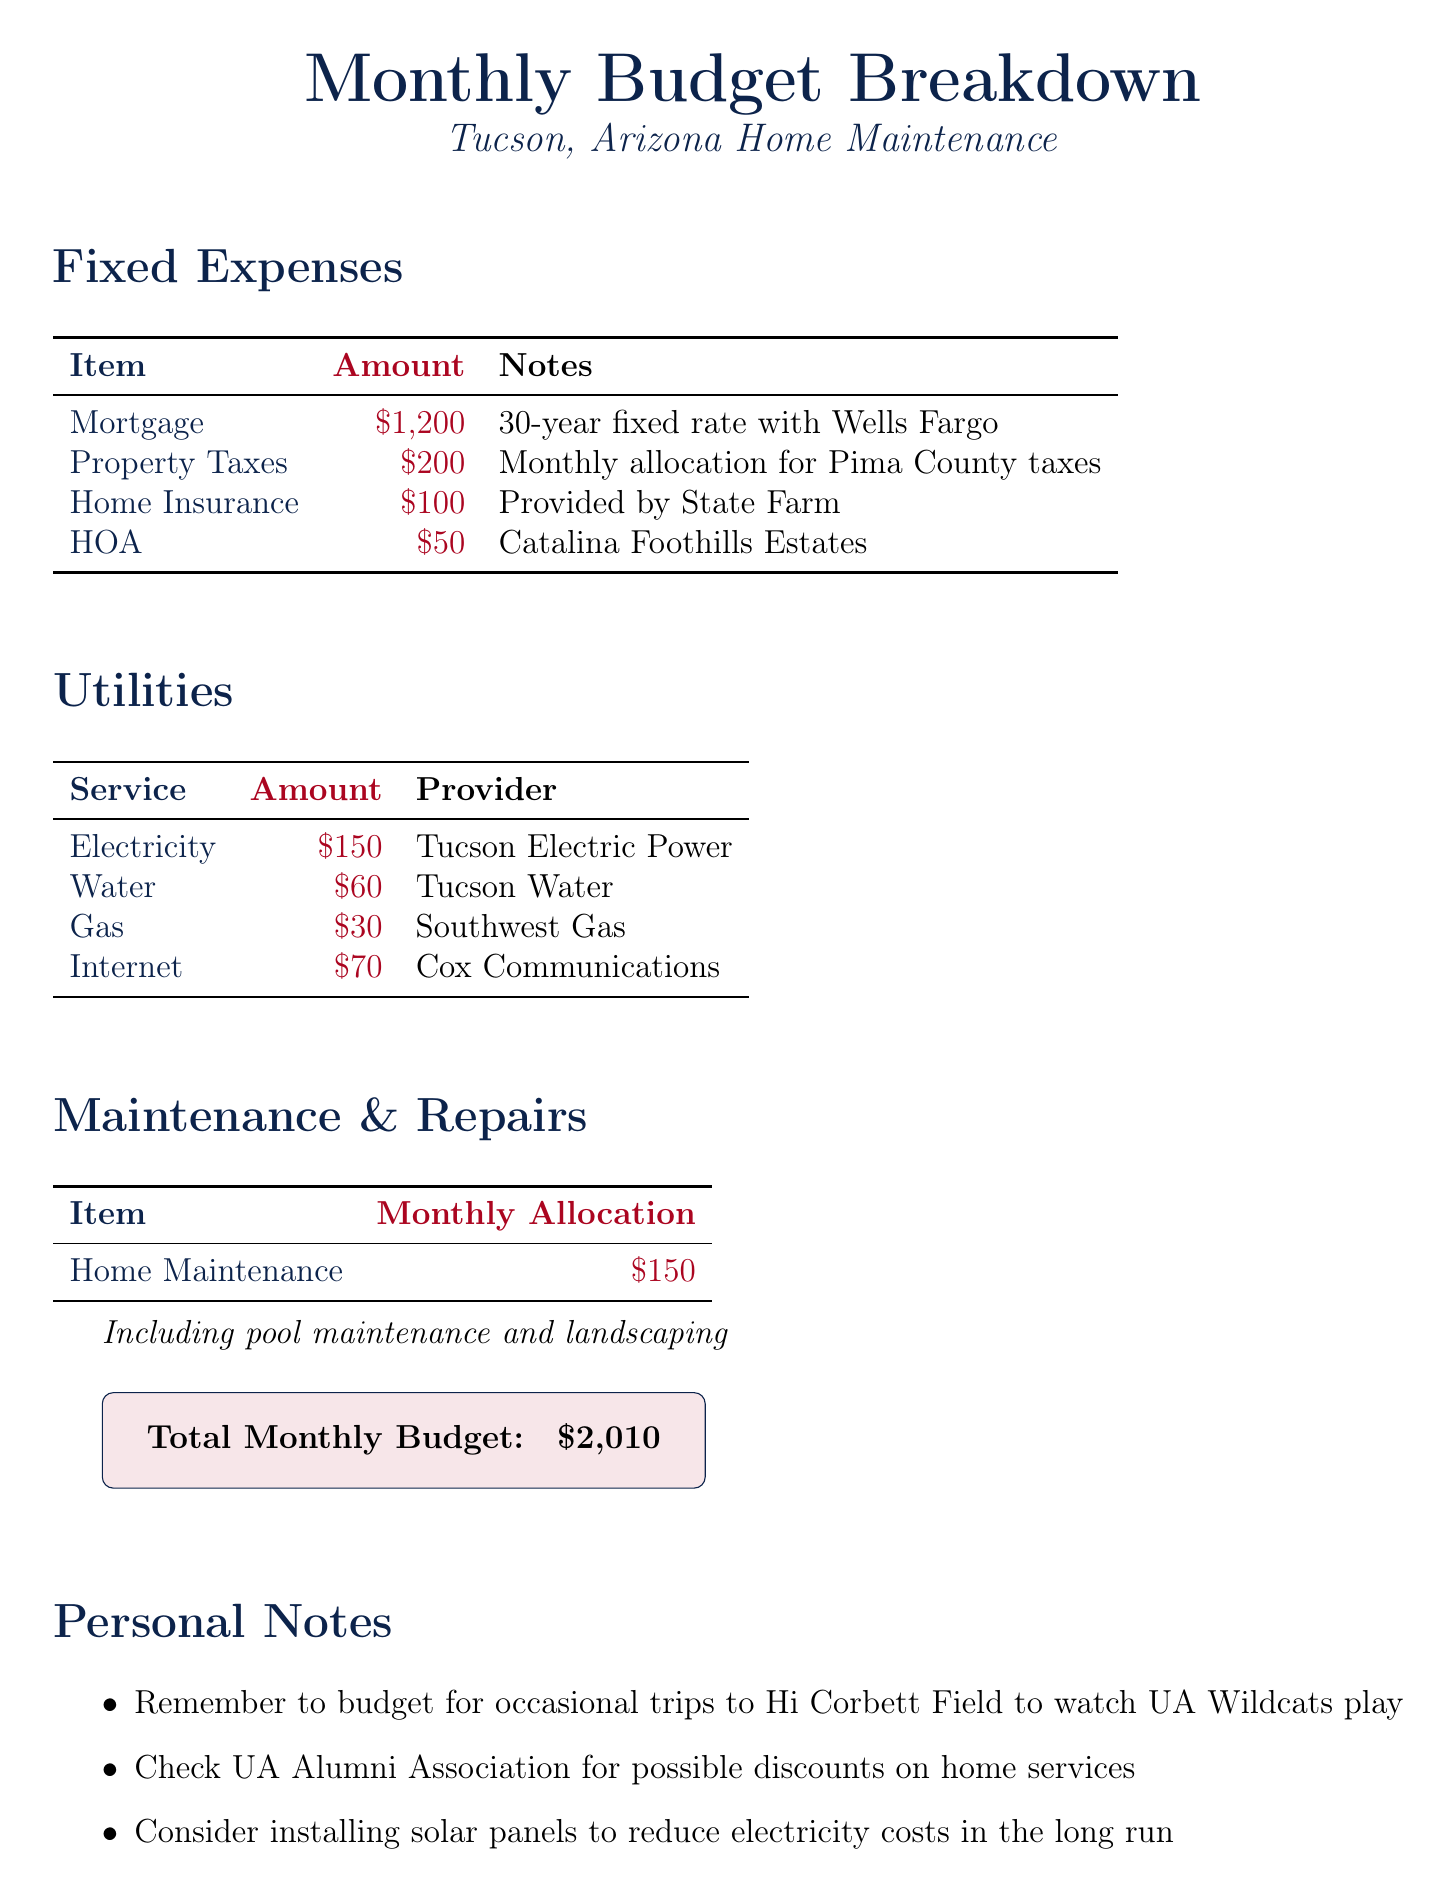What is the amount allocated for mortgage? The mortgage amount is listed as $1200 in the fixed expenses section.
Answer: $1200 Who provides the home insurance? The provider of home insurance is mentioned in the fixed expenses section as State Farm.
Answer: State Farm How much is allocated for electricity? The utilities section lists the electricity amount as $150.
Answer: $150 What is the total monthly budget? The total monthly budget is summarized at the end of the document as $2010.
Answer: $2010 What maintenance costs are included in home maintenance and repairs? The note mentions that home maintenance includes pool maintenance and landscaping.
Answer: Pool maintenance and landscaping What is the allocated amount for property taxes? The monthly allocation for property taxes is shown as $200.
Answer: $200 What local tip is provided in the personal notes? The personal notes suggest considering the installation of solar panels to reduce electricity costs.
Answer: Install solar panels What monthly amount is allocated to the HOA? The HOA section specifies a monthly allocation of $50.
Answer: $50 Which utility provider offers gas services? The gas provider listed in the utilities section is Southwest Gas.
Answer: Southwest Gas 